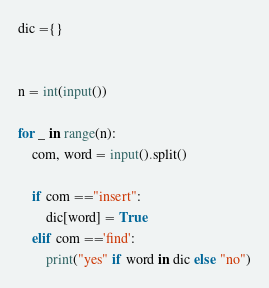Convert code to text. <code><loc_0><loc_0><loc_500><loc_500><_Python_>dic ={}


n = int(input())

for _ in range(n):
    com, word = input().split()
    
    if com =="insert":
        dic[word] = True
    elif com =='find':
        print("yes" if word in dic else "no")
</code> 